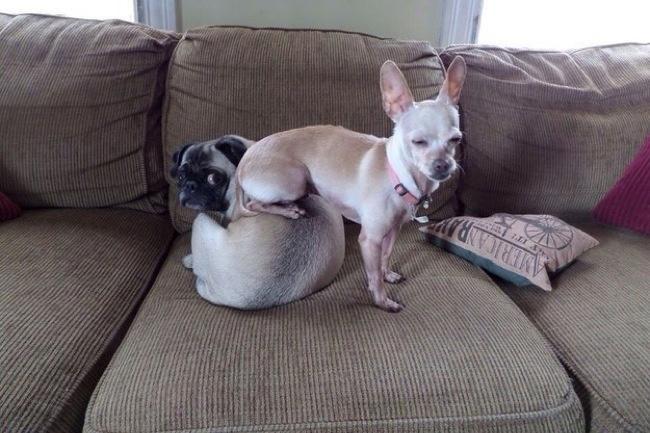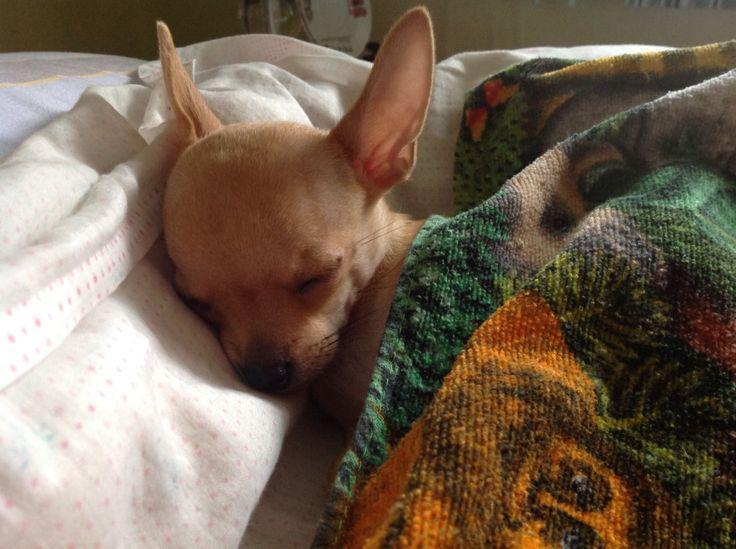The first image is the image on the left, the second image is the image on the right. For the images displayed, is the sentence "At least one chihuahua is sleeping on its back on a cozy blanket." factually correct? Answer yes or no. No. The first image is the image on the left, the second image is the image on the right. Assess this claim about the two images: "The left image shows two chihuahuas in sleeping poses side-by-side, and the right image shows one snoozing chihuahua on solid-colored fabric.". Correct or not? Answer yes or no. No. 